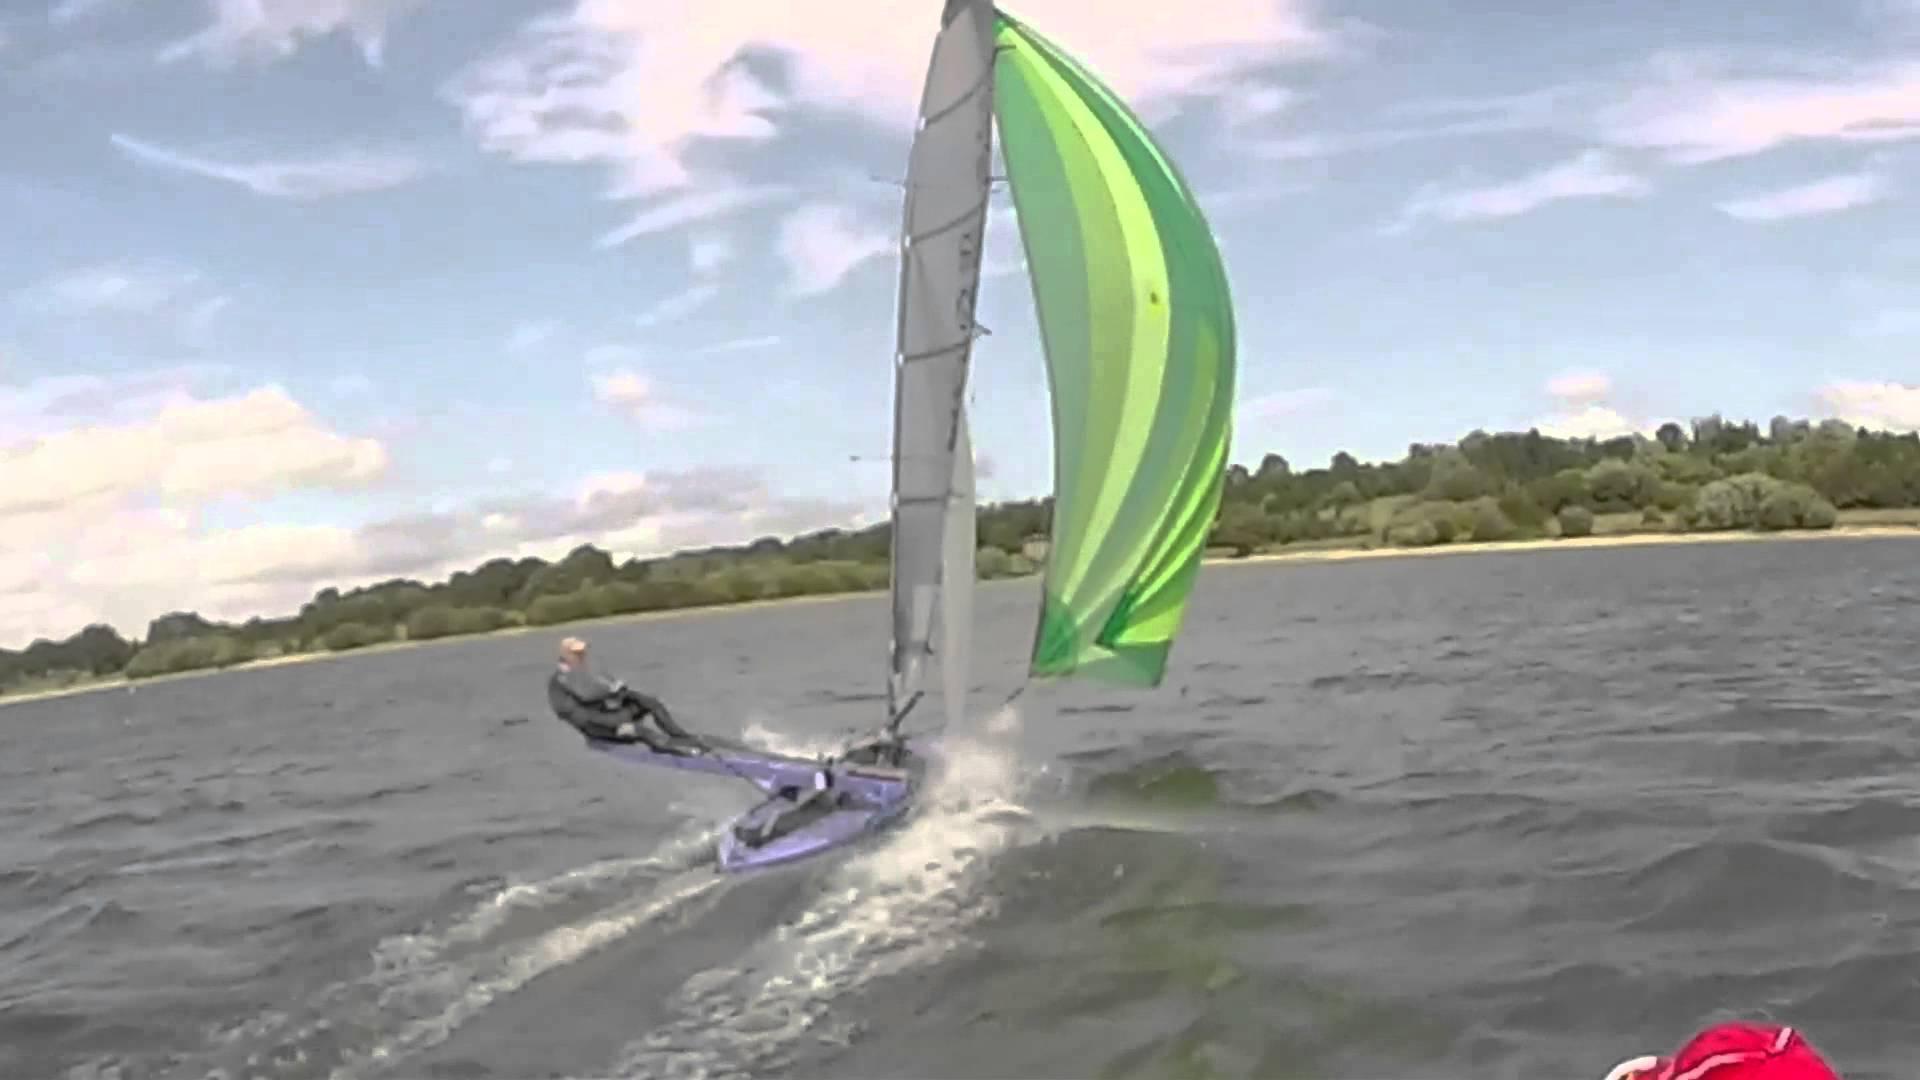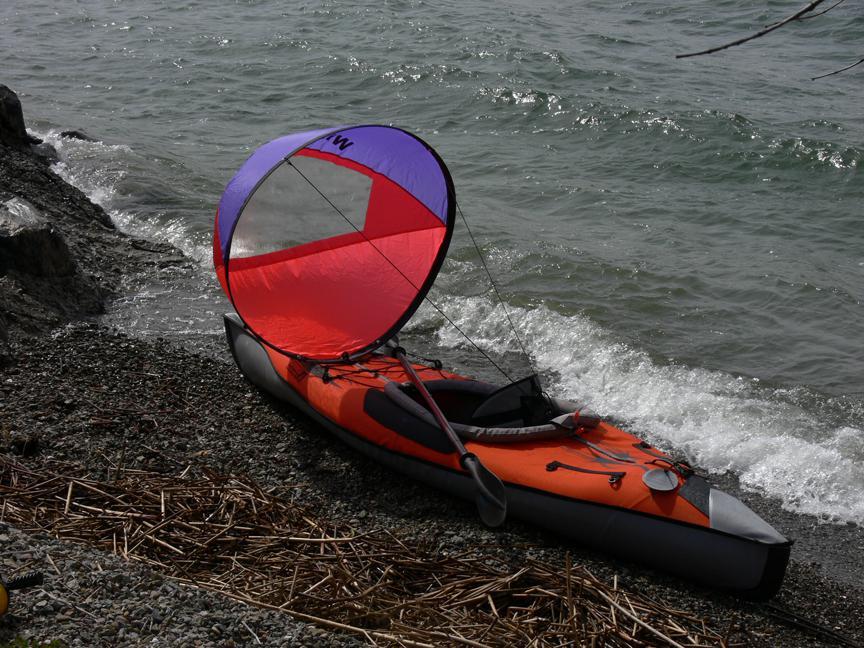The first image is the image on the left, the second image is the image on the right. For the images displayed, is the sentence "One of the boats appears to have been grounded on the beach; the boat can easily be used again later." factually correct? Answer yes or no. Yes. 